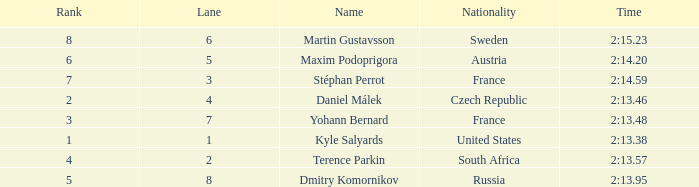What was Maxim Podoprigora's lowest rank? 6.0. 